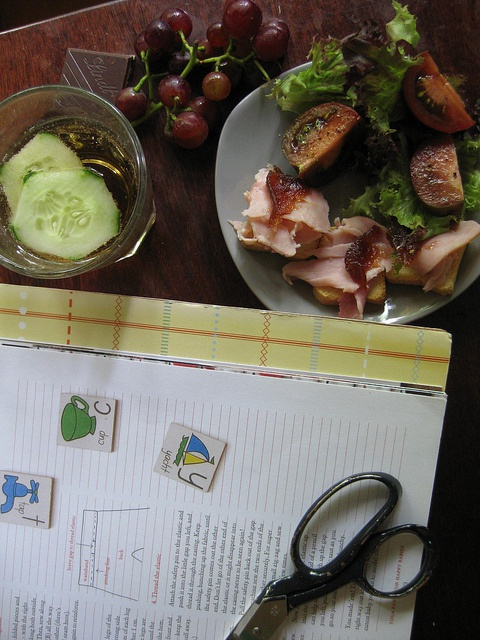Describe the objects in this image and their specific colors. I can see book in black, darkgray, tan, and lightgray tones, cup in black, olive, and maroon tones, scissors in black, gray, darkgray, and darkgreen tones, and bowl in black and gray tones in this image. 